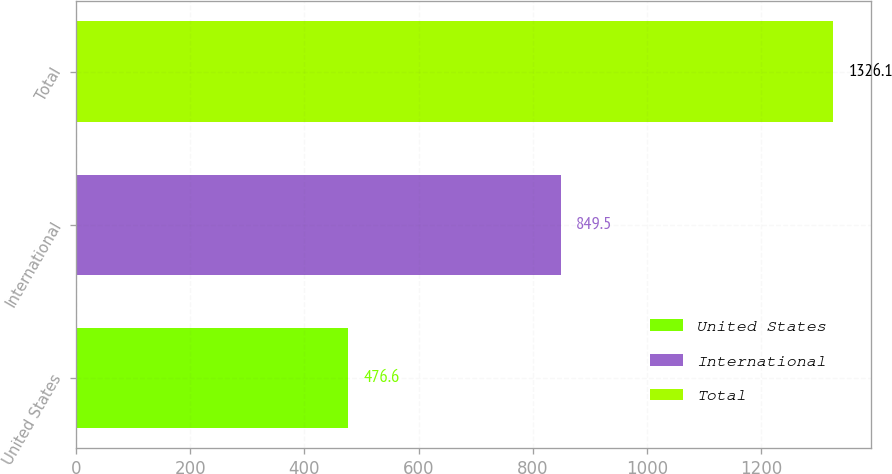Convert chart to OTSL. <chart><loc_0><loc_0><loc_500><loc_500><bar_chart><fcel>United States<fcel>International<fcel>Total<nl><fcel>476.6<fcel>849.5<fcel>1326.1<nl></chart> 